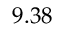<formula> <loc_0><loc_0><loc_500><loc_500>9 . 3 8</formula> 